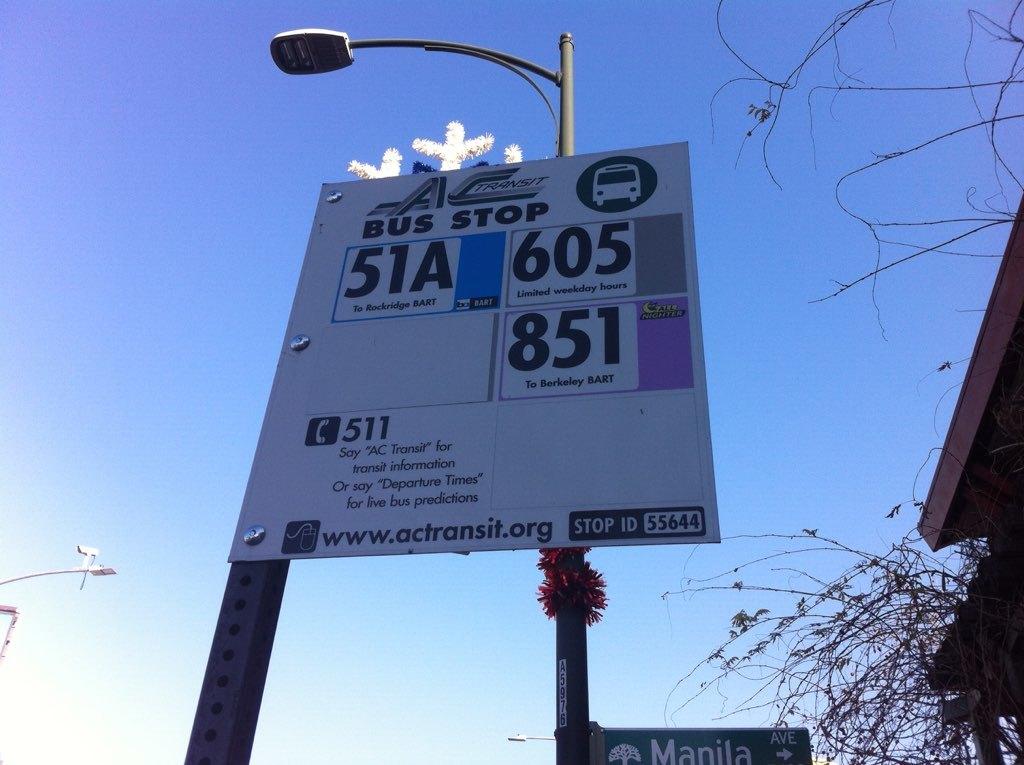What is the highest bus number that stops at this stop?
Your answer should be compact. 851. What is the lowest bus number that stops at this stop?
Your answer should be very brief. 51a. 